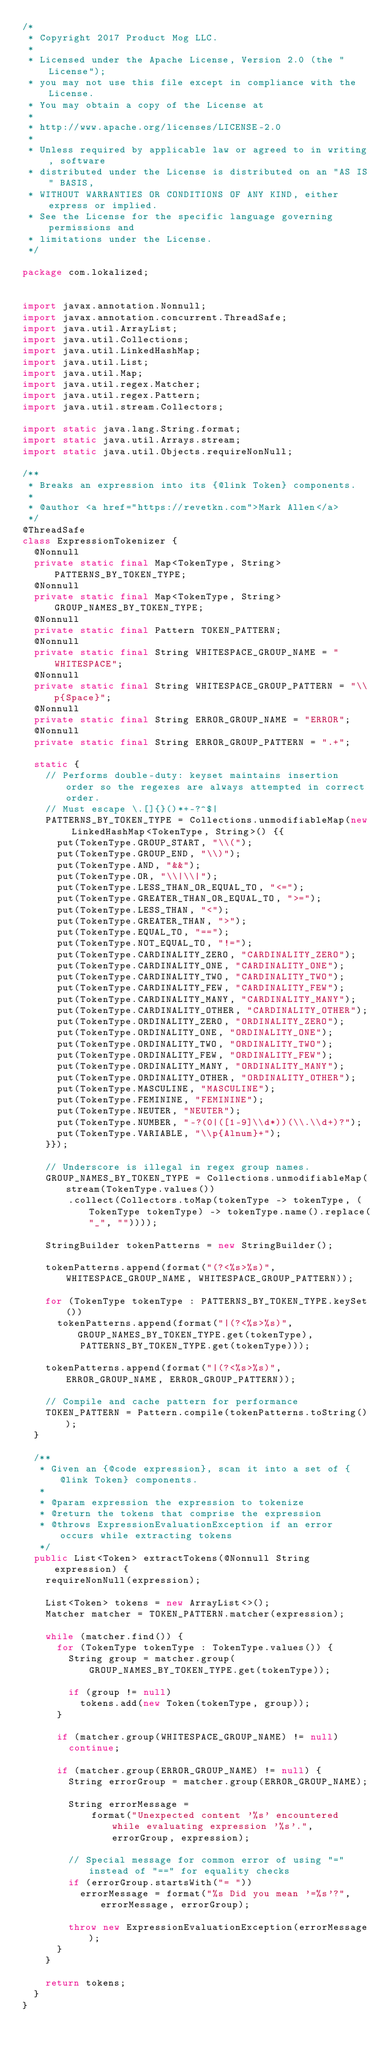Convert code to text. <code><loc_0><loc_0><loc_500><loc_500><_Java_>/*
 * Copyright 2017 Product Mog LLC.
 *
 * Licensed under the Apache License, Version 2.0 (the "License");
 * you may not use this file except in compliance with the License.
 * You may obtain a copy of the License at
 *
 * http://www.apache.org/licenses/LICENSE-2.0
 *
 * Unless required by applicable law or agreed to in writing, software
 * distributed under the License is distributed on an "AS IS" BASIS,
 * WITHOUT WARRANTIES OR CONDITIONS OF ANY KIND, either express or implied.
 * See the License for the specific language governing permissions and
 * limitations under the License.
 */

package com.lokalized;


import javax.annotation.Nonnull;
import javax.annotation.concurrent.ThreadSafe;
import java.util.ArrayList;
import java.util.Collections;
import java.util.LinkedHashMap;
import java.util.List;
import java.util.Map;
import java.util.regex.Matcher;
import java.util.regex.Pattern;
import java.util.stream.Collectors;

import static java.lang.String.format;
import static java.util.Arrays.stream;
import static java.util.Objects.requireNonNull;

/**
 * Breaks an expression into its {@link Token} components.
 *
 * @author <a href="https://revetkn.com">Mark Allen</a>
 */
@ThreadSafe
class ExpressionTokenizer {
  @Nonnull
  private static final Map<TokenType, String> PATTERNS_BY_TOKEN_TYPE;
  @Nonnull
  private static final Map<TokenType, String> GROUP_NAMES_BY_TOKEN_TYPE;
  @Nonnull
  private static final Pattern TOKEN_PATTERN;
  @Nonnull
  private static final String WHITESPACE_GROUP_NAME = "WHITESPACE";
  @Nonnull
  private static final String WHITESPACE_GROUP_PATTERN = "\\p{Space}";
  @Nonnull
  private static final String ERROR_GROUP_NAME = "ERROR";
  @Nonnull
  private static final String ERROR_GROUP_PATTERN = ".+";

  static {
    // Performs double-duty: keyset maintains insertion order so the regexes are always attempted in correct order.
    // Must escape \.[]{}()*+-?^$|
    PATTERNS_BY_TOKEN_TYPE = Collections.unmodifiableMap(new LinkedHashMap<TokenType, String>() {{
      put(TokenType.GROUP_START, "\\(");
      put(TokenType.GROUP_END, "\\)");
      put(TokenType.AND, "&&");
      put(TokenType.OR, "\\|\\|");
      put(TokenType.LESS_THAN_OR_EQUAL_TO, "<=");
      put(TokenType.GREATER_THAN_OR_EQUAL_TO, ">=");
      put(TokenType.LESS_THAN, "<");
      put(TokenType.GREATER_THAN, ">");
      put(TokenType.EQUAL_TO, "==");
      put(TokenType.NOT_EQUAL_TO, "!=");
      put(TokenType.CARDINALITY_ZERO, "CARDINALITY_ZERO");
      put(TokenType.CARDINALITY_ONE, "CARDINALITY_ONE");
      put(TokenType.CARDINALITY_TWO, "CARDINALITY_TWO");
      put(TokenType.CARDINALITY_FEW, "CARDINALITY_FEW");
      put(TokenType.CARDINALITY_MANY, "CARDINALITY_MANY");
      put(TokenType.CARDINALITY_OTHER, "CARDINALITY_OTHER");
      put(TokenType.ORDINALITY_ZERO, "ORDINALITY_ZERO");
      put(TokenType.ORDINALITY_ONE, "ORDINALITY_ONE");
      put(TokenType.ORDINALITY_TWO, "ORDINALITY_TWO");
      put(TokenType.ORDINALITY_FEW, "ORDINALITY_FEW");
      put(TokenType.ORDINALITY_MANY, "ORDINALITY_MANY");
      put(TokenType.ORDINALITY_OTHER, "ORDINALITY_OTHER");
      put(TokenType.MASCULINE, "MASCULINE");
      put(TokenType.FEMININE, "FEMININE");
      put(TokenType.NEUTER, "NEUTER");
      put(TokenType.NUMBER, "-?(0|([1-9]\\d*))(\\.\\d+)?");
      put(TokenType.VARIABLE, "\\p{Alnum}+");
    }});

    // Underscore is illegal in regex group names.
    GROUP_NAMES_BY_TOKEN_TYPE = Collections.unmodifiableMap(stream(TokenType.values())
        .collect(Collectors.toMap(tokenType -> tokenType, (TokenType tokenType) -> tokenType.name().replace("_", ""))));

    StringBuilder tokenPatterns = new StringBuilder();

    tokenPatterns.append(format("(?<%s>%s)", WHITESPACE_GROUP_NAME, WHITESPACE_GROUP_PATTERN));

    for (TokenType tokenType : PATTERNS_BY_TOKEN_TYPE.keySet())
      tokenPatterns.append(format("|(?<%s>%s)", GROUP_NAMES_BY_TOKEN_TYPE.get(tokenType),
          PATTERNS_BY_TOKEN_TYPE.get(tokenType)));

    tokenPatterns.append(format("|(?<%s>%s)", ERROR_GROUP_NAME, ERROR_GROUP_PATTERN));

    // Compile and cache pattern for performance
    TOKEN_PATTERN = Pattern.compile(tokenPatterns.toString());
  }

  /**
   * Given an {@code expression}, scan it into a set of {@link Token} components.
   *
   * @param expression the expression to tokenize
   * @return the tokens that comprise the expression
   * @throws ExpressionEvaluationException if an error occurs while extracting tokens
   */
  public List<Token> extractTokens(@Nonnull String expression) {
    requireNonNull(expression);

    List<Token> tokens = new ArrayList<>();
    Matcher matcher = TOKEN_PATTERN.matcher(expression);

    while (matcher.find()) {
      for (TokenType tokenType : TokenType.values()) {
        String group = matcher.group(GROUP_NAMES_BY_TOKEN_TYPE.get(tokenType));

        if (group != null)
          tokens.add(new Token(tokenType, group));
      }

      if (matcher.group(WHITESPACE_GROUP_NAME) != null)
        continue;

      if (matcher.group(ERROR_GROUP_NAME) != null) {
        String errorGroup = matcher.group(ERROR_GROUP_NAME);

        String errorMessage =
            format("Unexpected content '%s' encountered while evaluating expression '%s'.", errorGroup, expression);

        // Special message for common error of using "=" instead of "==" for equality checks
        if (errorGroup.startsWith("= "))
          errorMessage = format("%s Did you mean '=%s'?", errorMessage, errorGroup);

        throw new ExpressionEvaluationException(errorMessage);
      }
    }

    return tokens;
  }
}</code> 